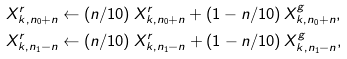Convert formula to latex. <formula><loc_0><loc_0><loc_500><loc_500>X ^ { r } _ { k , n _ { 0 } + n } & \leftarrow ( n / 1 0 ) \, X ^ { r } _ { k , n _ { 0 } + n } + ( 1 - n / 1 0 ) \, X ^ { g } _ { k , n _ { 0 } + n } , \\ X ^ { r } _ { k , n _ { 1 } - n } & \leftarrow ( n / 1 0 ) \, X ^ { r } _ { k , n _ { 1 } - n } + ( 1 - n / 1 0 ) \, X ^ { g } _ { k , n _ { 1 } - n } ,</formula> 